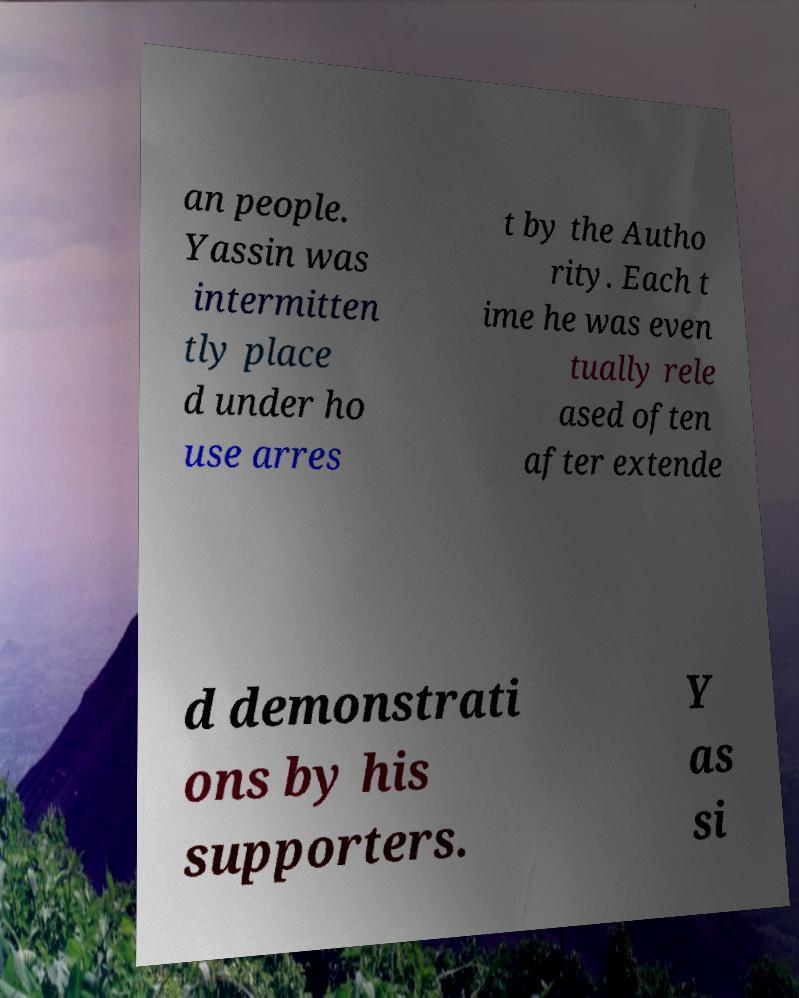Can you read and provide the text displayed in the image?This photo seems to have some interesting text. Can you extract and type it out for me? an people. Yassin was intermitten tly place d under ho use arres t by the Autho rity. Each t ime he was even tually rele ased often after extende d demonstrati ons by his supporters. Y as si 